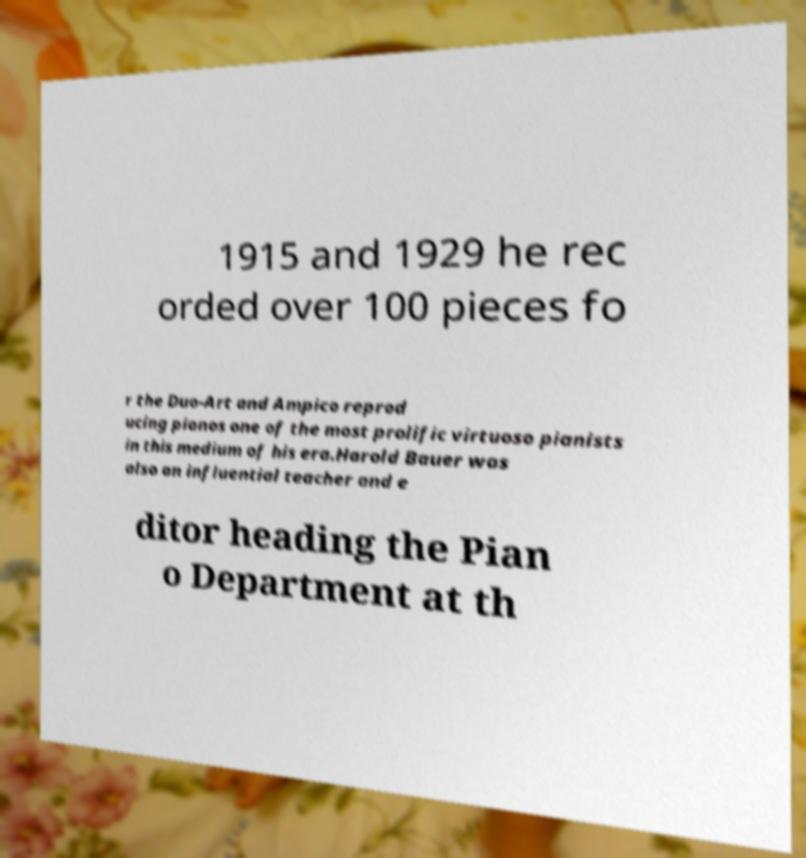Can you accurately transcribe the text from the provided image for me? 1915 and 1929 he rec orded over 100 pieces fo r the Duo-Art and Ampico reprod ucing pianos one of the most prolific virtuoso pianists in this medium of his era.Harold Bauer was also an influential teacher and e ditor heading the Pian o Department at th 